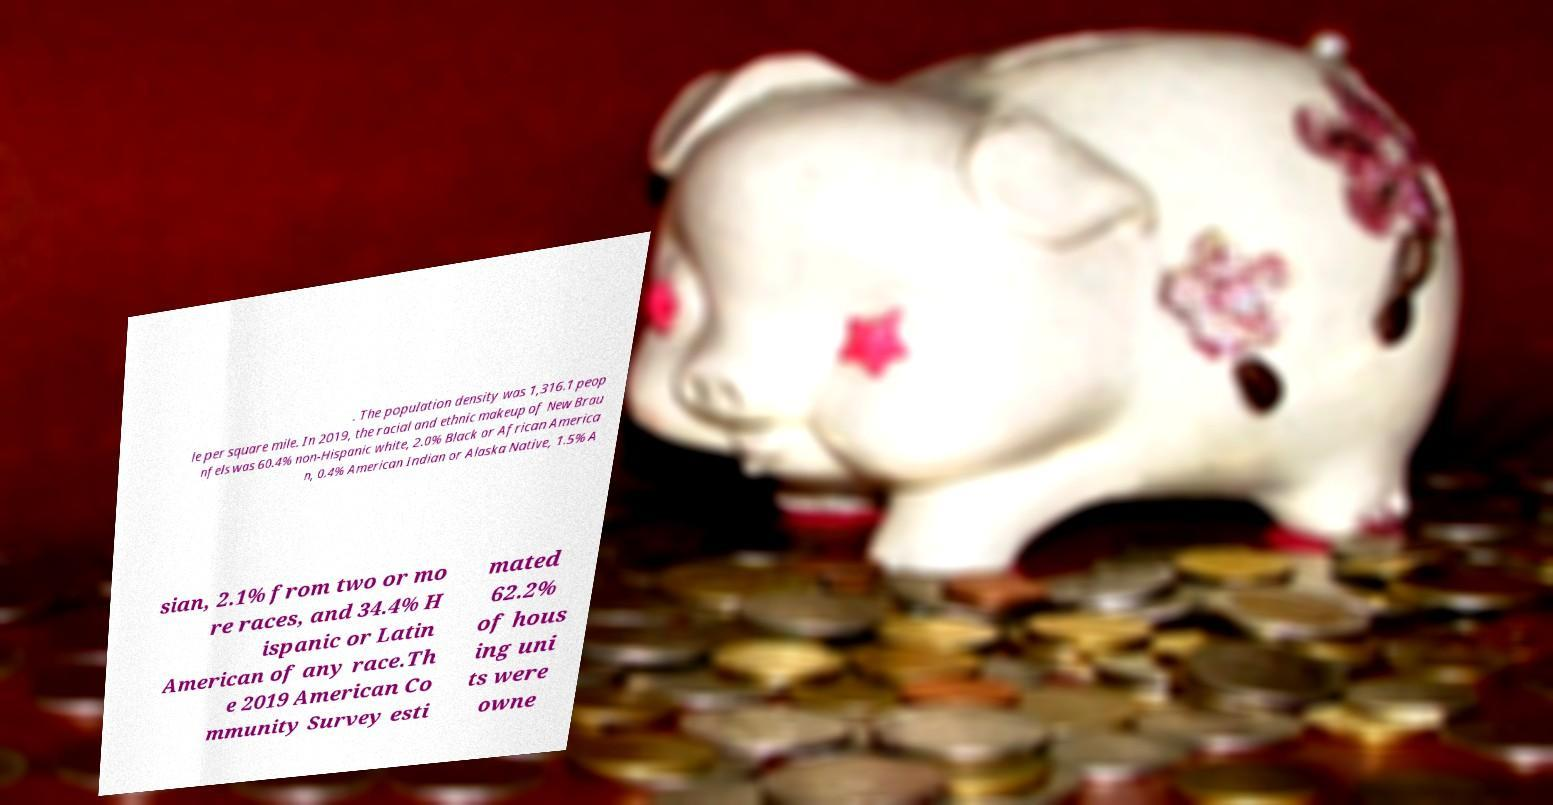What messages or text are displayed in this image? I need them in a readable, typed format. . The population density was 1,316.1 peop le per square mile. In 2019, the racial and ethnic makeup of New Brau nfels was 60.4% non-Hispanic white, 2.0% Black or African America n, 0.4% American Indian or Alaska Native, 1.5% A sian, 2.1% from two or mo re races, and 34.4% H ispanic or Latin American of any race.Th e 2019 American Co mmunity Survey esti mated 62.2% of hous ing uni ts were owne 